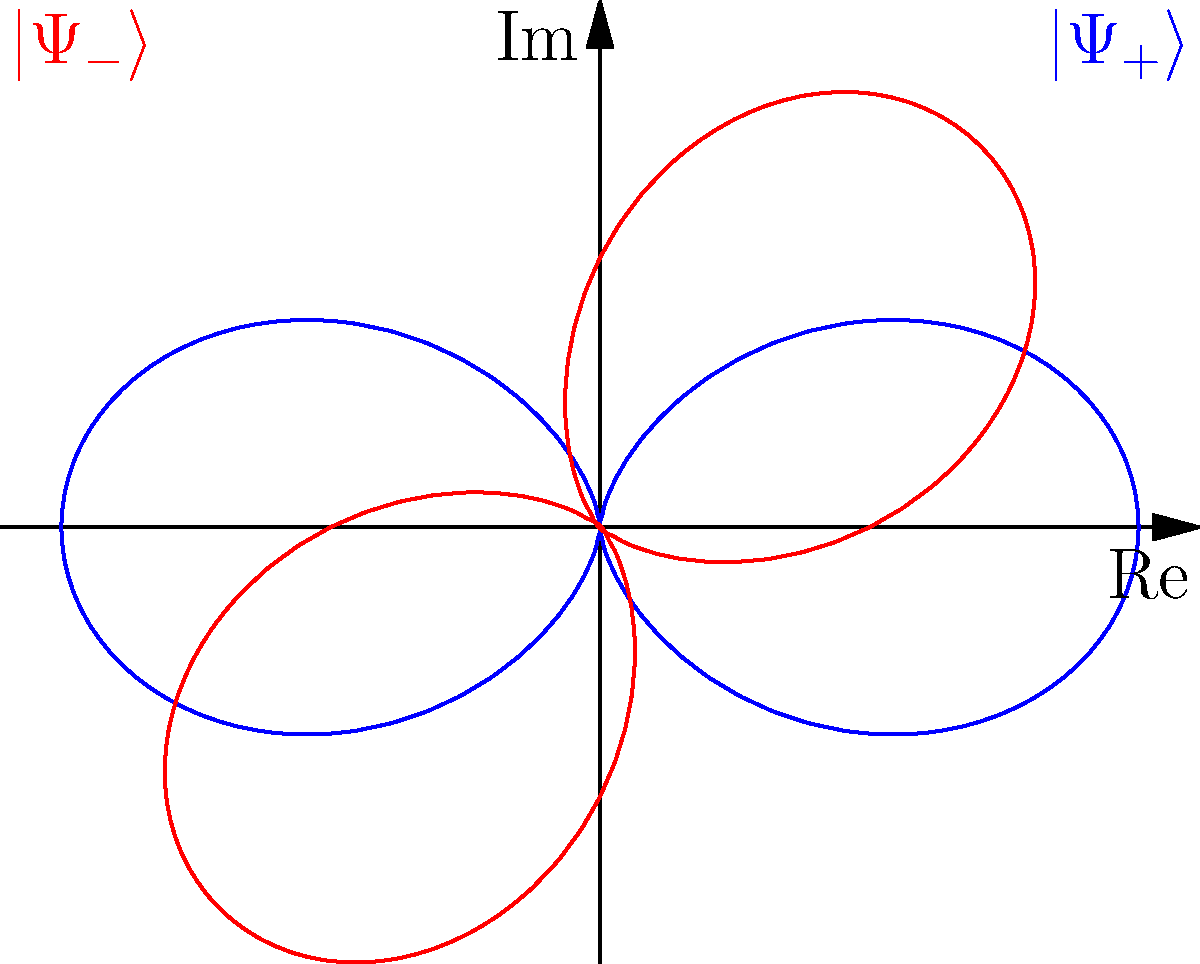Consider the polar coordinate plots representing two entangled quantum states $|\Psi_+\rangle$ (blue) and $|\Psi_-\rangle$ (red). What fundamental property of quantum entanglement is visually demonstrated by the orthogonality of these plots, and how does this relate to the proposed challenge to conventional quantum mechanics? To answer this question, let's analyze the graph step-by-step:

1) The blue curve represents $|\Psi_+\rangle$ and the red curve represents $|\Psi_-\rangle$. These are likely the Bell states, which are maximally entangled quantum states.

2) The curves are orthogonal to each other, meaning they are perpendicular at every point where they intersect. This orthogonality visually represents the fact that these states are mutually exclusive and cannot be described by the same quantum state.

3) In quantum mechanics, orthogonal states represent distinct measurement outcomes. The orthogonality of these curves demonstrates the principle of superposition and measurement in quantum mechanics.

4) The shape of each curve (a figure-eight) suggests that the states have equal probability amplitudes in two bases, which is a characteristic of maximally entangled states.

5) The symmetry of the curves around both axes illustrates the non-local nature of quantum entanglement, where measuring one particle instantaneously affects the state of the other, regardless of distance.

6) This visual representation challenges conventional quantum mechanics by suggesting a geometric interpretation of entanglement. It implies that entanglement might be understood as a fundamental geometric property of quantum states in a higher-dimensional space, rather than just a mathematical correlation.

7) The continuous nature of the curves might also suggest a hidden variable theory, challenging the probabilistic interpretation of standard quantum mechanics.

This representation provides a novel way to visualize quantum entanglement, potentially leading to new insights about the nature of quantum reality and the foundations of quantum mechanics.
Answer: Orthogonality of entangled states, suggesting a geometric interpretation of entanglement that challenges probabilistic quantum mechanics. 